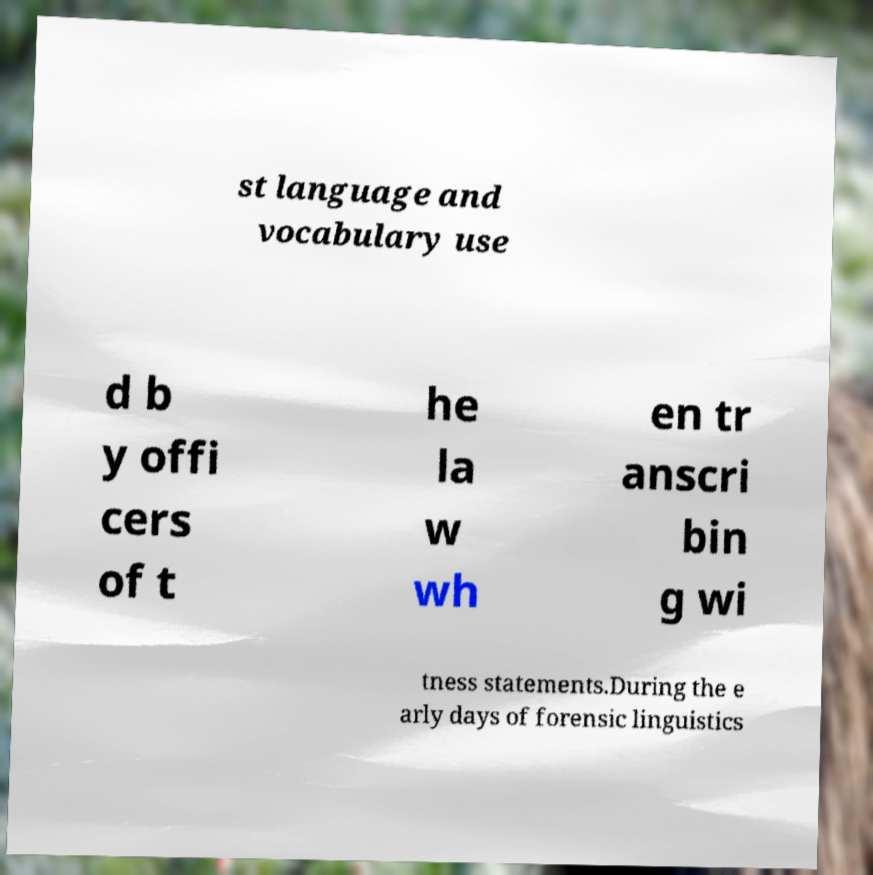Can you accurately transcribe the text from the provided image for me? st language and vocabulary use d b y offi cers of t he la w wh en tr anscri bin g wi tness statements.During the e arly days of forensic linguistics 